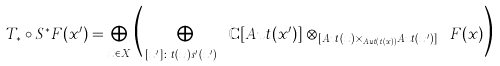Convert formula to latex. <formula><loc_0><loc_0><loc_500><loc_500>T _ { \ast } \circ S ^ { \ast } F ( x ^ { \prime } ) = \bigoplus _ { x \in X } \Big { ( } \bigoplus _ { [ x ^ { \prime } ] \colon t ( x ) \cong s ^ { \prime } ( x ^ { \prime } ) } \mathbb { C } [ A u t ( { x ^ { \prime } } ) ] \otimes _ { \mathbb { C } [ A u t ( x ) \times _ { A u t ( t ( x ) ) } A u t ( { x ^ { \prime } } ) ] } F ( x ) \Big { ) }</formula> 